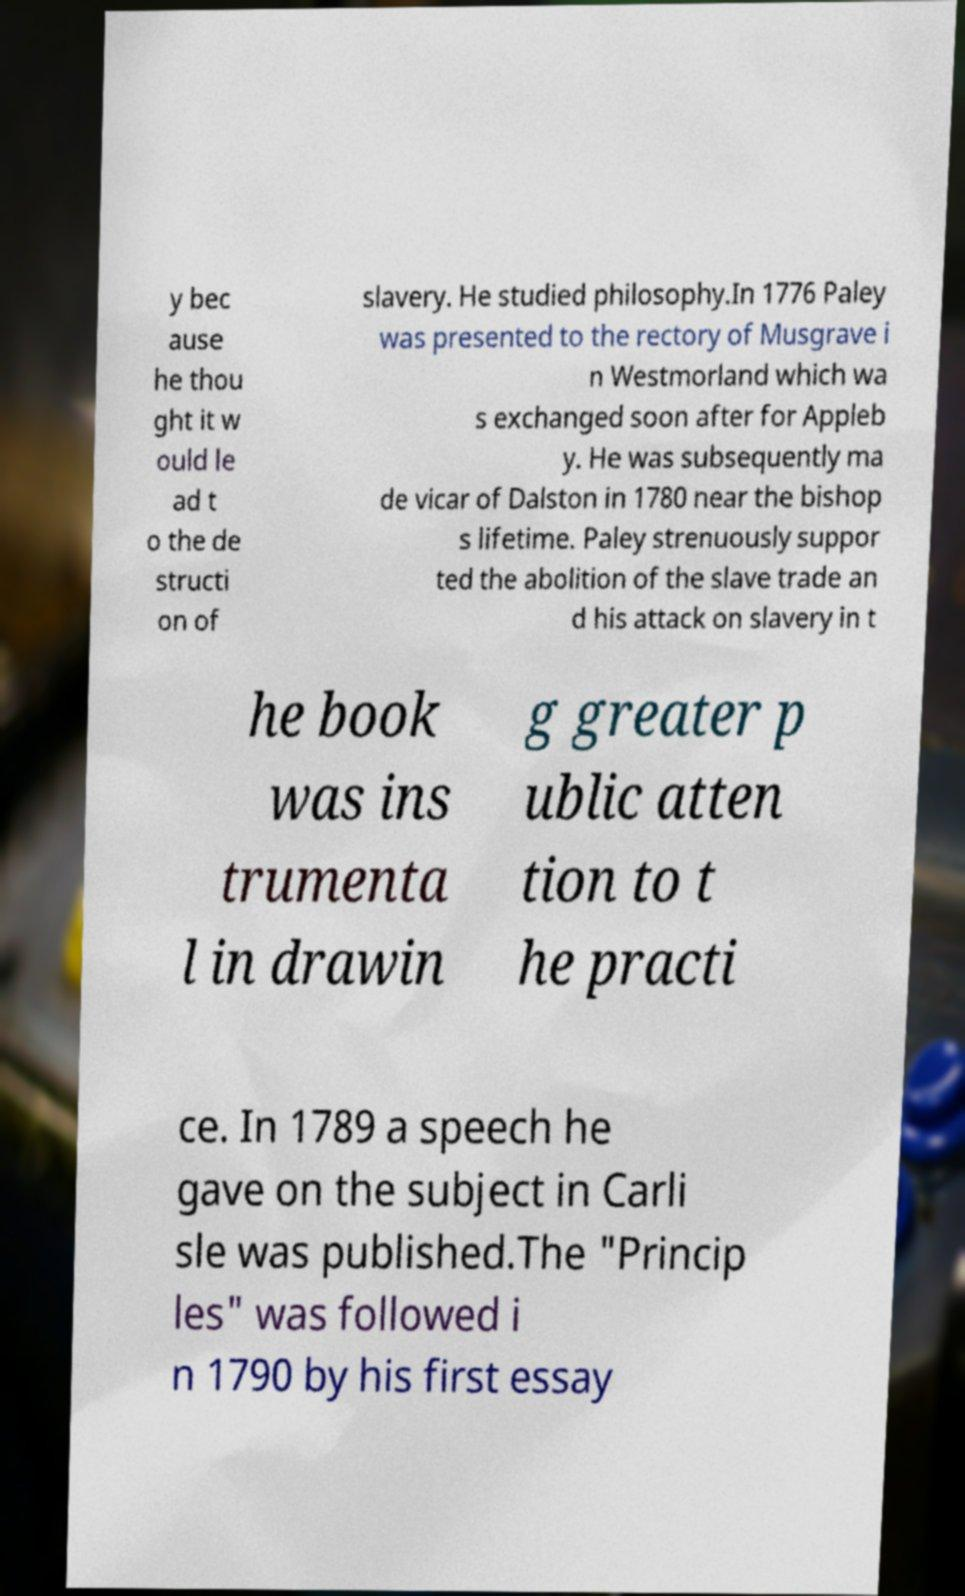For documentation purposes, I need the text within this image transcribed. Could you provide that? y bec ause he thou ght it w ould le ad t o the de structi on of slavery. He studied philosophy.In 1776 Paley was presented to the rectory of Musgrave i n Westmorland which wa s exchanged soon after for Appleb y. He was subsequently ma de vicar of Dalston in 1780 near the bishop s lifetime. Paley strenuously suppor ted the abolition of the slave trade an d his attack on slavery in t he book was ins trumenta l in drawin g greater p ublic atten tion to t he practi ce. In 1789 a speech he gave on the subject in Carli sle was published.The "Princip les" was followed i n 1790 by his first essay 